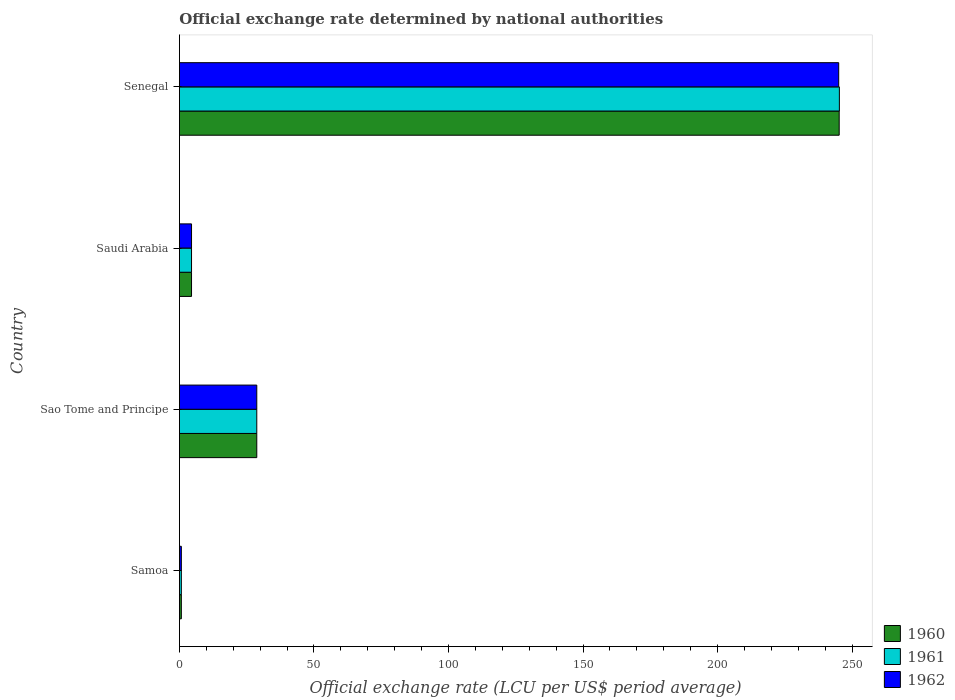What is the label of the 1st group of bars from the top?
Give a very brief answer. Senegal. In how many cases, is the number of bars for a given country not equal to the number of legend labels?
Provide a succinct answer. 0. What is the official exchange rate in 1962 in Saudi Arabia?
Offer a very short reply. 4.5. Across all countries, what is the maximum official exchange rate in 1962?
Keep it short and to the point. 245.01. Across all countries, what is the minimum official exchange rate in 1960?
Keep it short and to the point. 0.71. In which country was the official exchange rate in 1962 maximum?
Offer a terse response. Senegal. In which country was the official exchange rate in 1961 minimum?
Offer a terse response. Samoa. What is the total official exchange rate in 1960 in the graph?
Give a very brief answer. 279.16. What is the difference between the official exchange rate in 1962 in Samoa and that in Senegal?
Ensure brevity in your answer.  -244.29. What is the difference between the official exchange rate in 1962 in Saudi Arabia and the official exchange rate in 1960 in Senegal?
Provide a succinct answer. -240.7. What is the average official exchange rate in 1962 per country?
Give a very brief answer. 69.75. What is the difference between the official exchange rate in 1961 and official exchange rate in 1962 in Saudi Arabia?
Ensure brevity in your answer.  0. What is the ratio of the official exchange rate in 1961 in Sao Tome and Principe to that in Senegal?
Give a very brief answer. 0.12. Is the official exchange rate in 1962 in Samoa less than that in Senegal?
Offer a very short reply. Yes. Is the difference between the official exchange rate in 1961 in Samoa and Saudi Arabia greater than the difference between the official exchange rate in 1962 in Samoa and Saudi Arabia?
Provide a succinct answer. No. What is the difference between the highest and the second highest official exchange rate in 1962?
Your answer should be very brief. 216.26. What is the difference between the highest and the lowest official exchange rate in 1960?
Provide a succinct answer. 244.48. In how many countries, is the official exchange rate in 1960 greater than the average official exchange rate in 1960 taken over all countries?
Offer a terse response. 1. Is the sum of the official exchange rate in 1962 in Saudi Arabia and Senegal greater than the maximum official exchange rate in 1960 across all countries?
Keep it short and to the point. Yes. What does the 2nd bar from the top in Samoa represents?
Offer a terse response. 1961. What does the 3rd bar from the bottom in Samoa represents?
Your response must be concise. 1962. Is it the case that in every country, the sum of the official exchange rate in 1962 and official exchange rate in 1960 is greater than the official exchange rate in 1961?
Offer a terse response. Yes. How many bars are there?
Offer a very short reply. 12. Does the graph contain any zero values?
Provide a succinct answer. No. Where does the legend appear in the graph?
Ensure brevity in your answer.  Bottom right. How many legend labels are there?
Your answer should be compact. 3. How are the legend labels stacked?
Your answer should be compact. Vertical. What is the title of the graph?
Provide a short and direct response. Official exchange rate determined by national authorities. Does "1988" appear as one of the legend labels in the graph?
Your answer should be compact. No. What is the label or title of the X-axis?
Ensure brevity in your answer.  Official exchange rate (LCU per US$ period average). What is the label or title of the Y-axis?
Make the answer very short. Country. What is the Official exchange rate (LCU per US$ period average) in 1960 in Samoa?
Provide a short and direct response. 0.71. What is the Official exchange rate (LCU per US$ period average) in 1961 in Samoa?
Keep it short and to the point. 0.72. What is the Official exchange rate (LCU per US$ period average) in 1962 in Samoa?
Make the answer very short. 0.72. What is the Official exchange rate (LCU per US$ period average) of 1960 in Sao Tome and Principe?
Provide a succinct answer. 28.75. What is the Official exchange rate (LCU per US$ period average) in 1961 in Sao Tome and Principe?
Offer a terse response. 28.75. What is the Official exchange rate (LCU per US$ period average) of 1962 in Sao Tome and Principe?
Give a very brief answer. 28.75. What is the Official exchange rate (LCU per US$ period average) of 1960 in Saudi Arabia?
Offer a very short reply. 4.5. What is the Official exchange rate (LCU per US$ period average) in 1961 in Saudi Arabia?
Ensure brevity in your answer.  4.5. What is the Official exchange rate (LCU per US$ period average) of 1962 in Saudi Arabia?
Your answer should be very brief. 4.5. What is the Official exchange rate (LCU per US$ period average) in 1960 in Senegal?
Your answer should be compact. 245.2. What is the Official exchange rate (LCU per US$ period average) of 1961 in Senegal?
Provide a short and direct response. 245.26. What is the Official exchange rate (LCU per US$ period average) in 1962 in Senegal?
Give a very brief answer. 245.01. Across all countries, what is the maximum Official exchange rate (LCU per US$ period average) of 1960?
Ensure brevity in your answer.  245.2. Across all countries, what is the maximum Official exchange rate (LCU per US$ period average) in 1961?
Your response must be concise. 245.26. Across all countries, what is the maximum Official exchange rate (LCU per US$ period average) of 1962?
Your answer should be compact. 245.01. Across all countries, what is the minimum Official exchange rate (LCU per US$ period average) of 1960?
Offer a terse response. 0.71. Across all countries, what is the minimum Official exchange rate (LCU per US$ period average) of 1961?
Give a very brief answer. 0.72. Across all countries, what is the minimum Official exchange rate (LCU per US$ period average) in 1962?
Offer a very short reply. 0.72. What is the total Official exchange rate (LCU per US$ period average) of 1960 in the graph?
Ensure brevity in your answer.  279.16. What is the total Official exchange rate (LCU per US$ period average) of 1961 in the graph?
Make the answer very short. 279.23. What is the total Official exchange rate (LCU per US$ period average) in 1962 in the graph?
Make the answer very short. 278.98. What is the difference between the Official exchange rate (LCU per US$ period average) in 1960 in Samoa and that in Sao Tome and Principe?
Your answer should be very brief. -28.04. What is the difference between the Official exchange rate (LCU per US$ period average) of 1961 in Samoa and that in Sao Tome and Principe?
Offer a very short reply. -28.03. What is the difference between the Official exchange rate (LCU per US$ period average) in 1962 in Samoa and that in Sao Tome and Principe?
Make the answer very short. -28.03. What is the difference between the Official exchange rate (LCU per US$ period average) of 1960 in Samoa and that in Saudi Arabia?
Ensure brevity in your answer.  -3.79. What is the difference between the Official exchange rate (LCU per US$ period average) of 1961 in Samoa and that in Saudi Arabia?
Provide a short and direct response. -3.78. What is the difference between the Official exchange rate (LCU per US$ period average) of 1962 in Samoa and that in Saudi Arabia?
Offer a very short reply. -3.78. What is the difference between the Official exchange rate (LCU per US$ period average) of 1960 in Samoa and that in Senegal?
Ensure brevity in your answer.  -244.48. What is the difference between the Official exchange rate (LCU per US$ period average) in 1961 in Samoa and that in Senegal?
Make the answer very short. -244.54. What is the difference between the Official exchange rate (LCU per US$ period average) in 1962 in Samoa and that in Senegal?
Your response must be concise. -244.29. What is the difference between the Official exchange rate (LCU per US$ period average) of 1960 in Sao Tome and Principe and that in Saudi Arabia?
Make the answer very short. 24.25. What is the difference between the Official exchange rate (LCU per US$ period average) of 1961 in Sao Tome and Principe and that in Saudi Arabia?
Your response must be concise. 24.25. What is the difference between the Official exchange rate (LCU per US$ period average) of 1962 in Sao Tome and Principe and that in Saudi Arabia?
Give a very brief answer. 24.25. What is the difference between the Official exchange rate (LCU per US$ period average) of 1960 in Sao Tome and Principe and that in Senegal?
Give a very brief answer. -216.45. What is the difference between the Official exchange rate (LCU per US$ period average) in 1961 in Sao Tome and Principe and that in Senegal?
Provide a succinct answer. -216.51. What is the difference between the Official exchange rate (LCU per US$ period average) of 1962 in Sao Tome and Principe and that in Senegal?
Offer a terse response. -216.26. What is the difference between the Official exchange rate (LCU per US$ period average) in 1960 in Saudi Arabia and that in Senegal?
Offer a very short reply. -240.7. What is the difference between the Official exchange rate (LCU per US$ period average) of 1961 in Saudi Arabia and that in Senegal?
Offer a terse response. -240.76. What is the difference between the Official exchange rate (LCU per US$ period average) in 1962 in Saudi Arabia and that in Senegal?
Your answer should be compact. -240.51. What is the difference between the Official exchange rate (LCU per US$ period average) in 1960 in Samoa and the Official exchange rate (LCU per US$ period average) in 1961 in Sao Tome and Principe?
Keep it short and to the point. -28.04. What is the difference between the Official exchange rate (LCU per US$ period average) of 1960 in Samoa and the Official exchange rate (LCU per US$ period average) of 1962 in Sao Tome and Principe?
Ensure brevity in your answer.  -28.04. What is the difference between the Official exchange rate (LCU per US$ period average) in 1961 in Samoa and the Official exchange rate (LCU per US$ period average) in 1962 in Sao Tome and Principe?
Your response must be concise. -28.03. What is the difference between the Official exchange rate (LCU per US$ period average) in 1960 in Samoa and the Official exchange rate (LCU per US$ period average) in 1961 in Saudi Arabia?
Give a very brief answer. -3.79. What is the difference between the Official exchange rate (LCU per US$ period average) in 1960 in Samoa and the Official exchange rate (LCU per US$ period average) in 1962 in Saudi Arabia?
Offer a very short reply. -3.79. What is the difference between the Official exchange rate (LCU per US$ period average) in 1961 in Samoa and the Official exchange rate (LCU per US$ period average) in 1962 in Saudi Arabia?
Offer a very short reply. -3.78. What is the difference between the Official exchange rate (LCU per US$ period average) of 1960 in Samoa and the Official exchange rate (LCU per US$ period average) of 1961 in Senegal?
Provide a short and direct response. -244.55. What is the difference between the Official exchange rate (LCU per US$ period average) of 1960 in Samoa and the Official exchange rate (LCU per US$ period average) of 1962 in Senegal?
Give a very brief answer. -244.3. What is the difference between the Official exchange rate (LCU per US$ period average) in 1961 in Samoa and the Official exchange rate (LCU per US$ period average) in 1962 in Senegal?
Your response must be concise. -244.3. What is the difference between the Official exchange rate (LCU per US$ period average) in 1960 in Sao Tome and Principe and the Official exchange rate (LCU per US$ period average) in 1961 in Saudi Arabia?
Ensure brevity in your answer.  24.25. What is the difference between the Official exchange rate (LCU per US$ period average) in 1960 in Sao Tome and Principe and the Official exchange rate (LCU per US$ period average) in 1962 in Saudi Arabia?
Offer a terse response. 24.25. What is the difference between the Official exchange rate (LCU per US$ period average) of 1961 in Sao Tome and Principe and the Official exchange rate (LCU per US$ period average) of 1962 in Saudi Arabia?
Keep it short and to the point. 24.25. What is the difference between the Official exchange rate (LCU per US$ period average) of 1960 in Sao Tome and Principe and the Official exchange rate (LCU per US$ period average) of 1961 in Senegal?
Give a very brief answer. -216.51. What is the difference between the Official exchange rate (LCU per US$ period average) of 1960 in Sao Tome and Principe and the Official exchange rate (LCU per US$ period average) of 1962 in Senegal?
Your response must be concise. -216.26. What is the difference between the Official exchange rate (LCU per US$ period average) of 1961 in Sao Tome and Principe and the Official exchange rate (LCU per US$ period average) of 1962 in Senegal?
Your answer should be compact. -216.26. What is the difference between the Official exchange rate (LCU per US$ period average) in 1960 in Saudi Arabia and the Official exchange rate (LCU per US$ period average) in 1961 in Senegal?
Offer a terse response. -240.76. What is the difference between the Official exchange rate (LCU per US$ period average) of 1960 in Saudi Arabia and the Official exchange rate (LCU per US$ period average) of 1962 in Senegal?
Your answer should be compact. -240.51. What is the difference between the Official exchange rate (LCU per US$ period average) of 1961 in Saudi Arabia and the Official exchange rate (LCU per US$ period average) of 1962 in Senegal?
Make the answer very short. -240.51. What is the average Official exchange rate (LCU per US$ period average) in 1960 per country?
Offer a terse response. 69.79. What is the average Official exchange rate (LCU per US$ period average) of 1961 per country?
Make the answer very short. 69.81. What is the average Official exchange rate (LCU per US$ period average) of 1962 per country?
Provide a succinct answer. 69.75. What is the difference between the Official exchange rate (LCU per US$ period average) in 1960 and Official exchange rate (LCU per US$ period average) in 1961 in Samoa?
Your answer should be very brief. -0. What is the difference between the Official exchange rate (LCU per US$ period average) of 1960 and Official exchange rate (LCU per US$ period average) of 1962 in Samoa?
Keep it short and to the point. -0. What is the difference between the Official exchange rate (LCU per US$ period average) of 1961 and Official exchange rate (LCU per US$ period average) of 1962 in Samoa?
Your answer should be compact. -0. What is the difference between the Official exchange rate (LCU per US$ period average) of 1960 and Official exchange rate (LCU per US$ period average) of 1962 in Sao Tome and Principe?
Provide a short and direct response. 0. What is the difference between the Official exchange rate (LCU per US$ period average) in 1960 and Official exchange rate (LCU per US$ period average) in 1961 in Saudi Arabia?
Provide a short and direct response. 0. What is the difference between the Official exchange rate (LCU per US$ period average) of 1960 and Official exchange rate (LCU per US$ period average) of 1962 in Saudi Arabia?
Provide a succinct answer. 0. What is the difference between the Official exchange rate (LCU per US$ period average) in 1960 and Official exchange rate (LCU per US$ period average) in 1961 in Senegal?
Make the answer very short. -0.07. What is the difference between the Official exchange rate (LCU per US$ period average) in 1960 and Official exchange rate (LCU per US$ period average) in 1962 in Senegal?
Make the answer very short. 0.18. What is the difference between the Official exchange rate (LCU per US$ period average) in 1961 and Official exchange rate (LCU per US$ period average) in 1962 in Senegal?
Make the answer very short. 0.25. What is the ratio of the Official exchange rate (LCU per US$ period average) in 1960 in Samoa to that in Sao Tome and Principe?
Your answer should be very brief. 0.02. What is the ratio of the Official exchange rate (LCU per US$ period average) in 1961 in Samoa to that in Sao Tome and Principe?
Offer a terse response. 0.02. What is the ratio of the Official exchange rate (LCU per US$ period average) of 1962 in Samoa to that in Sao Tome and Principe?
Your response must be concise. 0.03. What is the ratio of the Official exchange rate (LCU per US$ period average) of 1960 in Samoa to that in Saudi Arabia?
Offer a very short reply. 0.16. What is the ratio of the Official exchange rate (LCU per US$ period average) in 1961 in Samoa to that in Saudi Arabia?
Give a very brief answer. 0.16. What is the ratio of the Official exchange rate (LCU per US$ period average) of 1962 in Samoa to that in Saudi Arabia?
Keep it short and to the point. 0.16. What is the ratio of the Official exchange rate (LCU per US$ period average) in 1960 in Samoa to that in Senegal?
Give a very brief answer. 0. What is the ratio of the Official exchange rate (LCU per US$ period average) in 1961 in Samoa to that in Senegal?
Your response must be concise. 0. What is the ratio of the Official exchange rate (LCU per US$ period average) in 1962 in Samoa to that in Senegal?
Ensure brevity in your answer.  0. What is the ratio of the Official exchange rate (LCU per US$ period average) of 1960 in Sao Tome and Principe to that in Saudi Arabia?
Give a very brief answer. 6.39. What is the ratio of the Official exchange rate (LCU per US$ period average) of 1961 in Sao Tome and Principe to that in Saudi Arabia?
Your response must be concise. 6.39. What is the ratio of the Official exchange rate (LCU per US$ period average) in 1962 in Sao Tome and Principe to that in Saudi Arabia?
Provide a short and direct response. 6.39. What is the ratio of the Official exchange rate (LCU per US$ period average) in 1960 in Sao Tome and Principe to that in Senegal?
Give a very brief answer. 0.12. What is the ratio of the Official exchange rate (LCU per US$ period average) of 1961 in Sao Tome and Principe to that in Senegal?
Give a very brief answer. 0.12. What is the ratio of the Official exchange rate (LCU per US$ period average) in 1962 in Sao Tome and Principe to that in Senegal?
Ensure brevity in your answer.  0.12. What is the ratio of the Official exchange rate (LCU per US$ period average) in 1960 in Saudi Arabia to that in Senegal?
Your response must be concise. 0.02. What is the ratio of the Official exchange rate (LCU per US$ period average) in 1961 in Saudi Arabia to that in Senegal?
Provide a short and direct response. 0.02. What is the ratio of the Official exchange rate (LCU per US$ period average) in 1962 in Saudi Arabia to that in Senegal?
Your answer should be very brief. 0.02. What is the difference between the highest and the second highest Official exchange rate (LCU per US$ period average) in 1960?
Your response must be concise. 216.45. What is the difference between the highest and the second highest Official exchange rate (LCU per US$ period average) of 1961?
Ensure brevity in your answer.  216.51. What is the difference between the highest and the second highest Official exchange rate (LCU per US$ period average) in 1962?
Your response must be concise. 216.26. What is the difference between the highest and the lowest Official exchange rate (LCU per US$ period average) in 1960?
Your answer should be compact. 244.48. What is the difference between the highest and the lowest Official exchange rate (LCU per US$ period average) in 1961?
Give a very brief answer. 244.54. What is the difference between the highest and the lowest Official exchange rate (LCU per US$ period average) in 1962?
Your response must be concise. 244.29. 